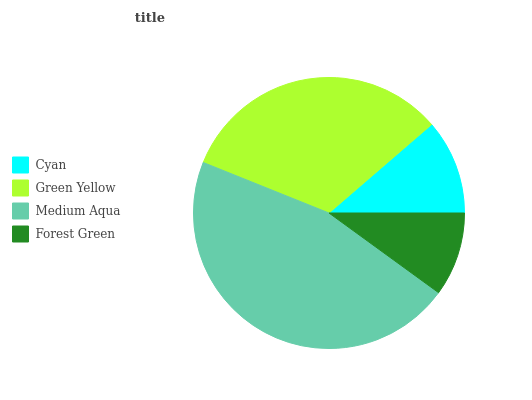Is Forest Green the minimum?
Answer yes or no. Yes. Is Medium Aqua the maximum?
Answer yes or no. Yes. Is Green Yellow the minimum?
Answer yes or no. No. Is Green Yellow the maximum?
Answer yes or no. No. Is Green Yellow greater than Cyan?
Answer yes or no. Yes. Is Cyan less than Green Yellow?
Answer yes or no. Yes. Is Cyan greater than Green Yellow?
Answer yes or no. No. Is Green Yellow less than Cyan?
Answer yes or no. No. Is Green Yellow the high median?
Answer yes or no. Yes. Is Cyan the low median?
Answer yes or no. Yes. Is Forest Green the high median?
Answer yes or no. No. Is Forest Green the low median?
Answer yes or no. No. 